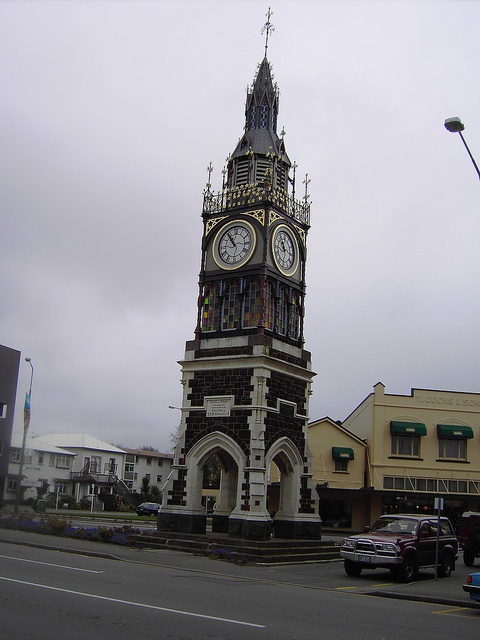Describe the objects in this image and their specific colors. I can see car in lavender, black, gray, darkgray, and navy tones, clock in lavender, gray, black, and tan tones, clock in lavender, gray, darkgray, black, and beige tones, car in lavender, black, gray, darkgreen, and navy tones, and car in lavender, black, gray, navy, and darkblue tones in this image. 